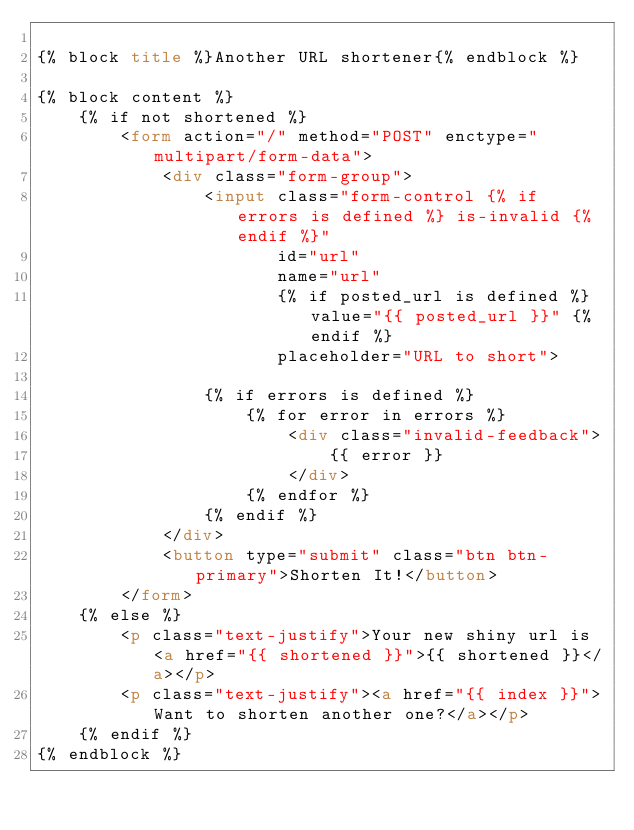Convert code to text. <code><loc_0><loc_0><loc_500><loc_500><_HTML_>
{% block title %}Another URL shortener{% endblock %}

{% block content %}
    {% if not shortened %}
        <form action="/" method="POST" enctype="multipart/form-data">
            <div class="form-group">
                <input class="form-control {% if errors is defined %} is-invalid {% endif %}"
                       id="url"
                       name="url"
                       {% if posted_url is defined %} value="{{ posted_url }}" {% endif %}
                       placeholder="URL to short">

                {% if errors is defined %}
                    {% for error in errors %}
                        <div class="invalid-feedback">
                            {{ error }}
                        </div>
                    {% endfor %}
                {% endif %}
            </div>
            <button type="submit" class="btn btn-primary">Shorten It!</button>
        </form>
    {% else %}
        <p class="text-justify">Your new shiny url is <a href="{{ shortened }}">{{ shortened }}</a></p>
        <p class="text-justify"><a href="{{ index }}">Want to shorten another one?</a></p>
    {% endif %}
{% endblock %}</code> 